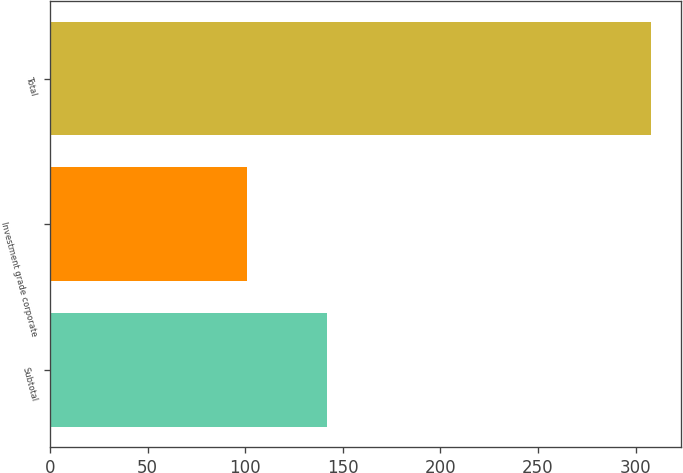Convert chart to OTSL. <chart><loc_0><loc_0><loc_500><loc_500><bar_chart><fcel>Subtotal<fcel>Investment grade corporate<fcel>Total<nl><fcel>142<fcel>101<fcel>308<nl></chart> 